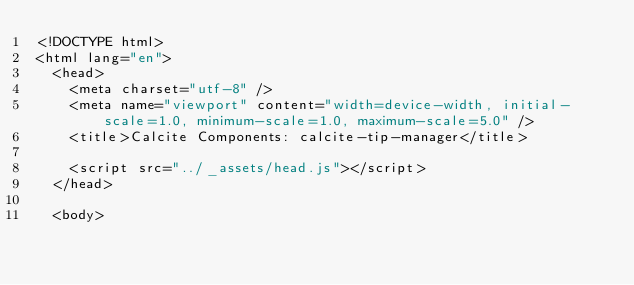<code> <loc_0><loc_0><loc_500><loc_500><_HTML_><!DOCTYPE html>
<html lang="en">
  <head>
    <meta charset="utf-8" />
    <meta name="viewport" content="width=device-width, initial-scale=1.0, minimum-scale=1.0, maximum-scale=5.0" />
    <title>Calcite Components: calcite-tip-manager</title>

    <script src="../_assets/head.js"></script>
  </head>

  <body></code> 